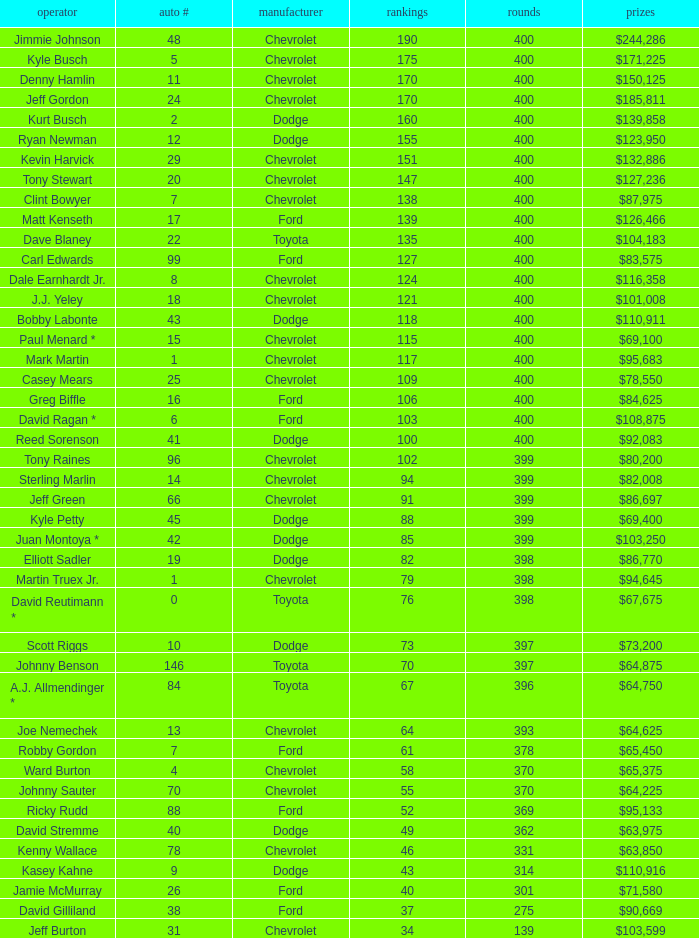What is the car number that has less than 369 laps for a Dodge with more than 49 points? None. 